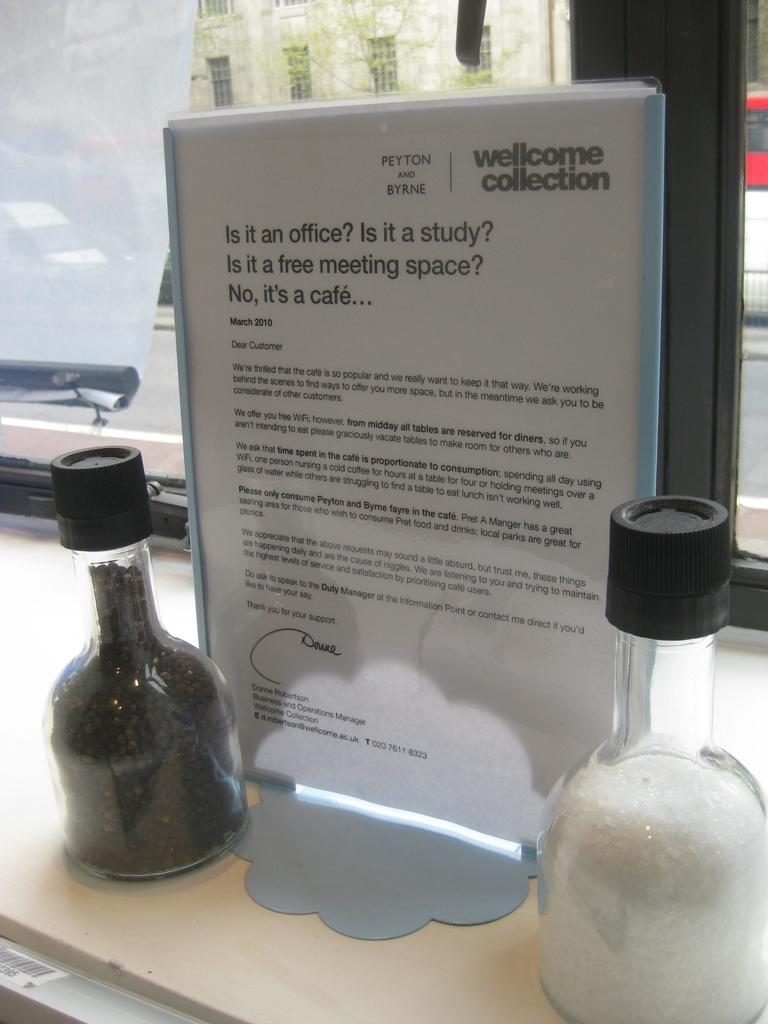In one or two sentences, can you explain what this image depicts? There are two glass Bottles And beside of this and it's paper file. 